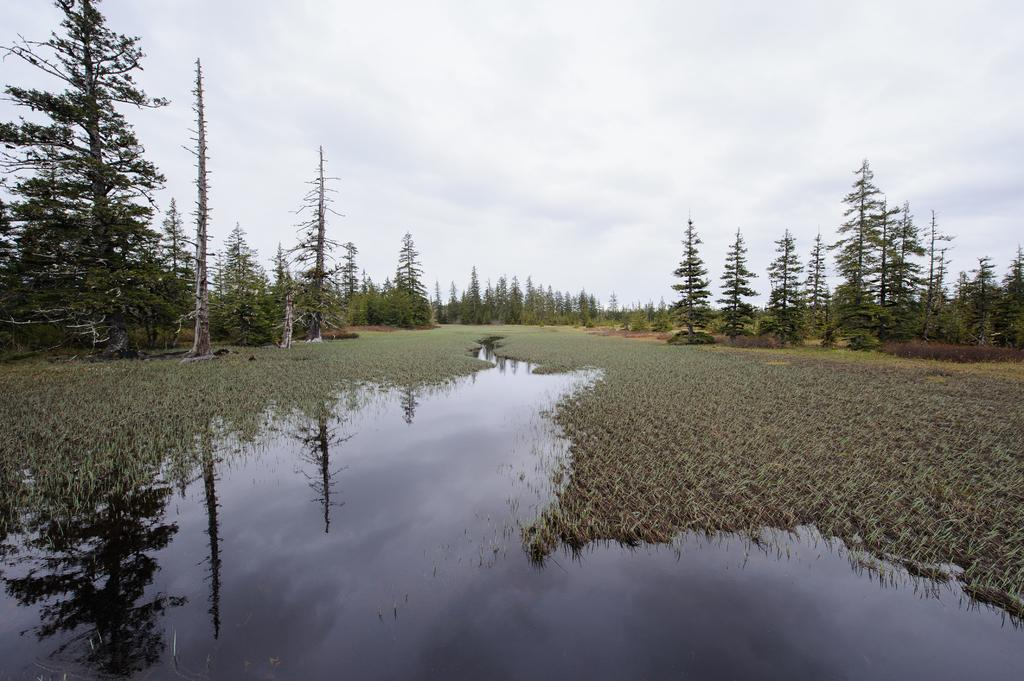What type of vegetation is present in the image? There is grass in the image. What natural element is also visible in the image? There is water in the image. What other type of vegetation can be seen in the image? There are trees in the image. What is visible in the background of the image? The sky is visible in the background of the image. What type of impulse can be seen affecting the stove in the image? There is no stove present in the image, and therefore no impulse affecting it. 